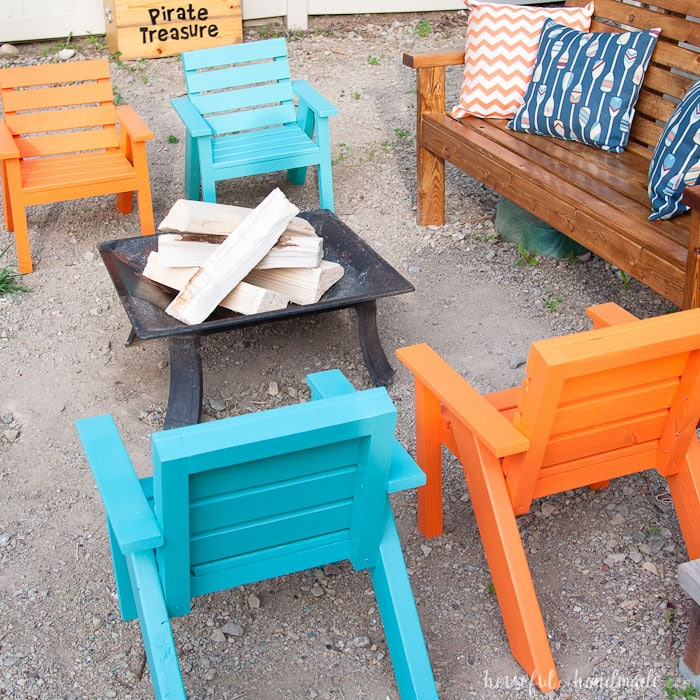How does the 'Pirate Treasure' sign contribute to the overall theme? The 'Pirate Treasure' sign introduces a playful and adventurous theme to the gathering. It suggests that the event might include themed activities such as a treasure hunt or pirate-themed games, adding an element of fun and excitement. This whimsical touch can engage guests of all ages and transform a simple gathering into a more memorable and immersive experience. Can you describe a scenario where this themed setting is particularly effective? Imagine a summer evening where children and adults alike gather for a 'Pirate Treasure' themed party. The setting features not only the colorful chairs and fire pit but also a map guiding guests to hidden 'treasures' around the yard. As the sun sets, the fire pit is lit, and everyone gathers to share their finds. Kids excitedly show off their pirate loot while adults enjoy drinks and conversation. The evening culminates in a storytelling session around the fire, with each guest adding to a tale of pirate adventures. This theme creates an atmosphere of camaraderie, excitement, and imaginative play. 